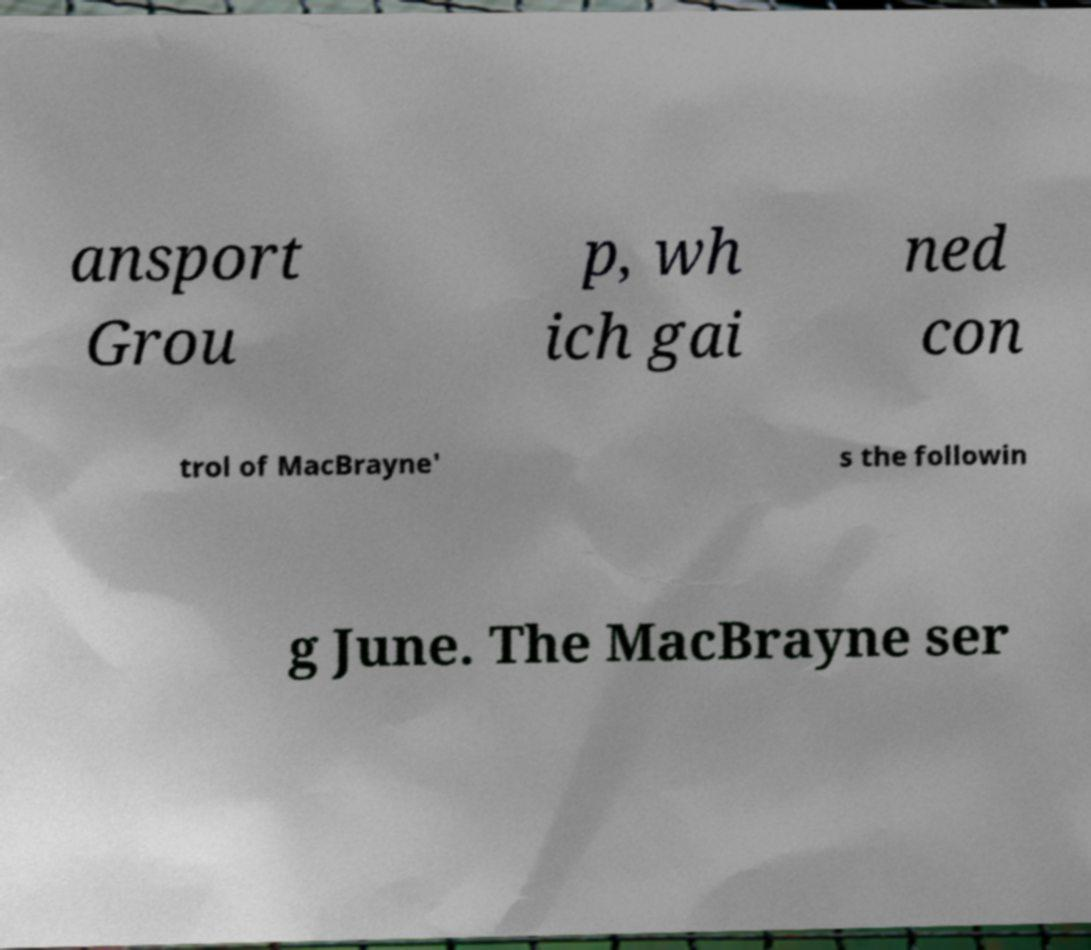Can you read and provide the text displayed in the image?This photo seems to have some interesting text. Can you extract and type it out for me? ansport Grou p, wh ich gai ned con trol of MacBrayne' s the followin g June. The MacBrayne ser 